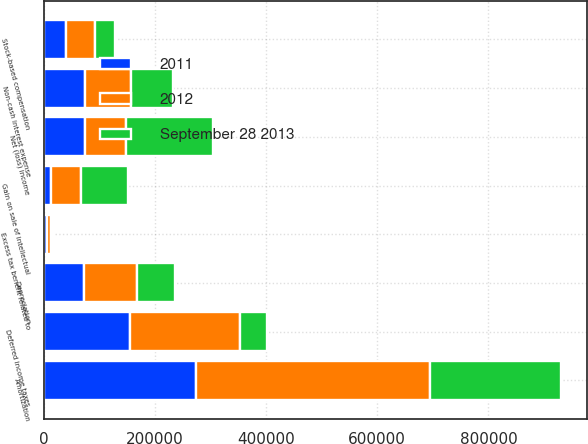Convert chart to OTSL. <chart><loc_0><loc_0><loc_500><loc_500><stacked_bar_chart><ecel><fcel>Net (loss) income<fcel>Depreciation<fcel>Amortization<fcel>Non-cash interest expense<fcel>Stock-based compensation<fcel>Excess tax benefit related to<fcel>Deferred income taxes<fcel>Gain on sale of intellectual<nl><fcel>2012<fcel>73634<fcel>95518<fcel>420492<fcel>81177<fcel>52307<fcel>7439<fcel>197983<fcel>53884<nl><fcel>2011<fcel>73634<fcel>71851<fcel>273900<fcel>74974<fcel>40572<fcel>6206<fcel>155192<fcel>12424<nl><fcel>September 28 2013<fcel>157150<fcel>68946<fcel>235790<fcel>76814<fcel>35472<fcel>3652<fcel>48107<fcel>84502<nl></chart> 